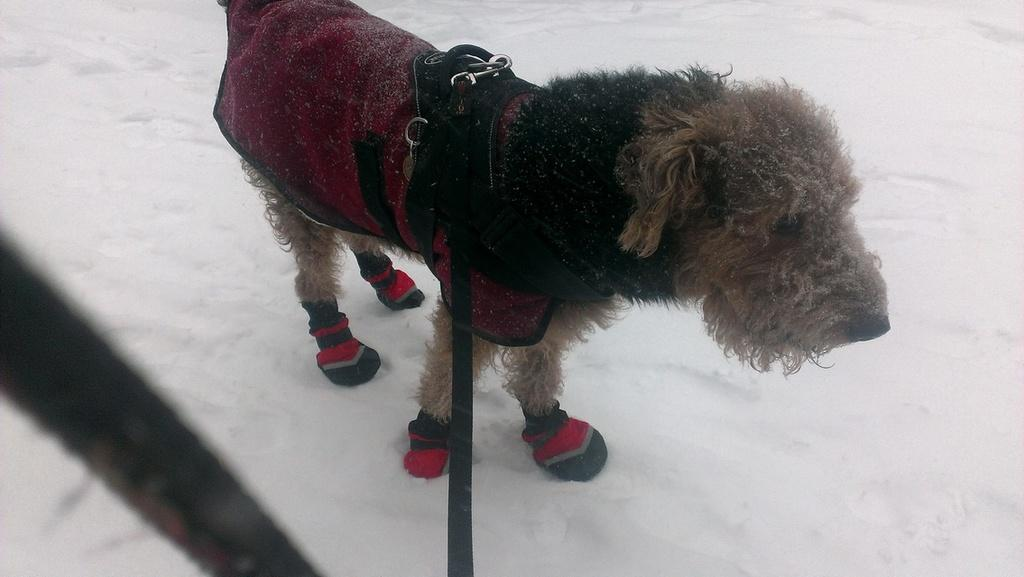What animal is present in the image? There is a dog in the image. What is the dog standing on? The dog is standing on the snow. What type of agreement does the dog have with the snow in the image? There is no agreement between the dog and the snow in the image; the dog is simply standing on the snow. 